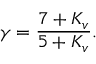Convert formula to latex. <formula><loc_0><loc_0><loc_500><loc_500>\gamma = \frac { 7 + K _ { v } } { 5 + K _ { v } } .</formula> 